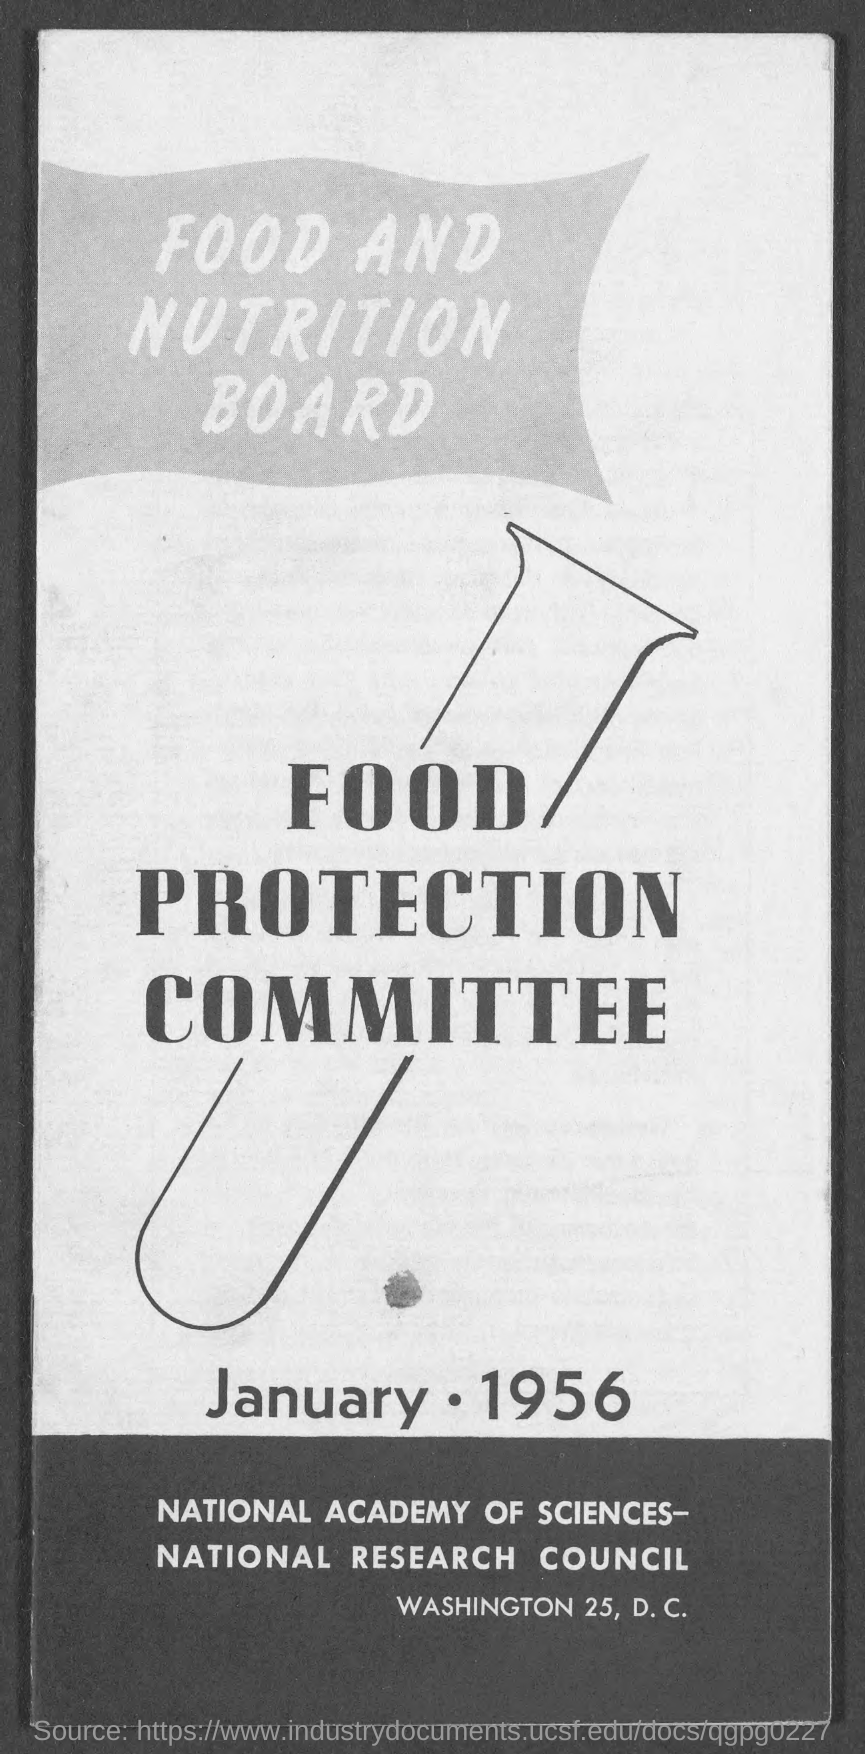Which committee is mentioned in the document?
Your answer should be compact. Food protection committee. 